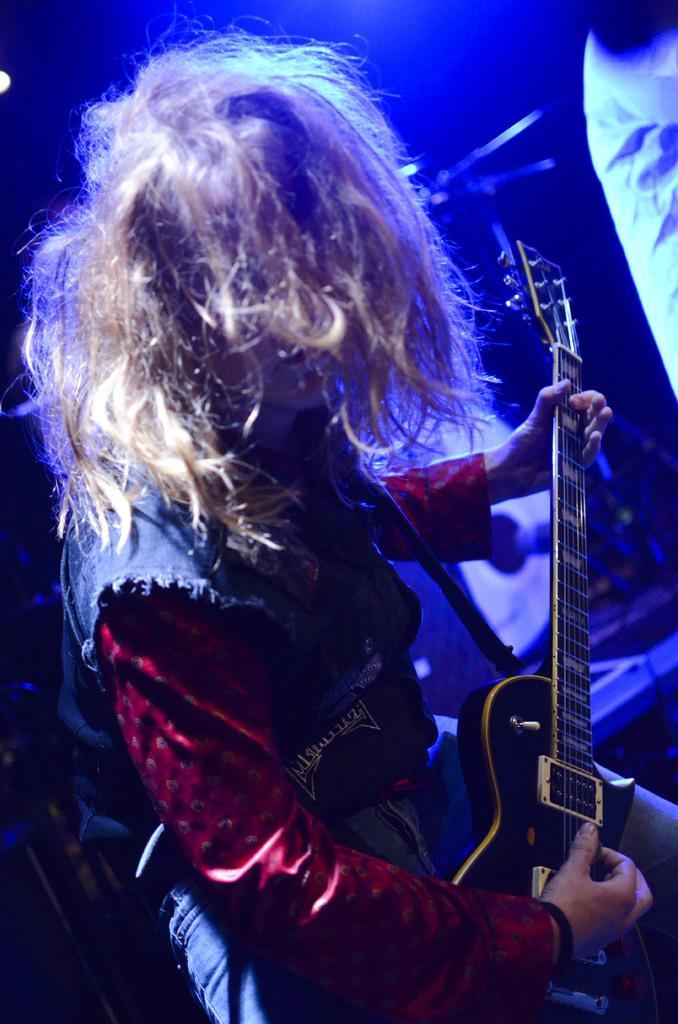What is the person in the image doing? The person is playing a guitar. How is the guitar being held by the person? The guitar is in the person's hand. Is there anyone else in the image? Yes, there is another person beside the first person. Can you describe the background of the image? The background of the image is not clear. What type of gun can be seen in the hands of the person playing the guitar? There is no gun present in the image; the person is playing a guitar. Is there a playground visible in the background of the image? There is no playground visible in the image; the background is not clear. 